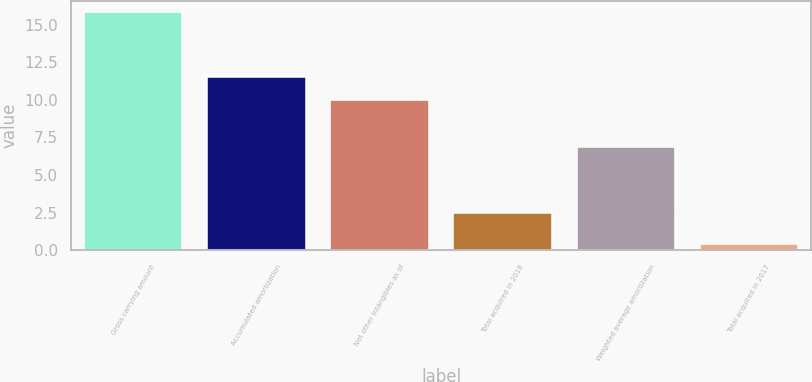Convert chart. <chart><loc_0><loc_0><loc_500><loc_500><bar_chart><fcel>Gross carrying amount<fcel>Accumulated amortization<fcel>Net other intangibles as of<fcel>Total acquired in 2018<fcel>Weighted average amortization<fcel>Total acquired in 2017<nl><fcel>15.8<fcel>11.52<fcel>9.98<fcel>2.5<fcel>6.9<fcel>0.4<nl></chart> 